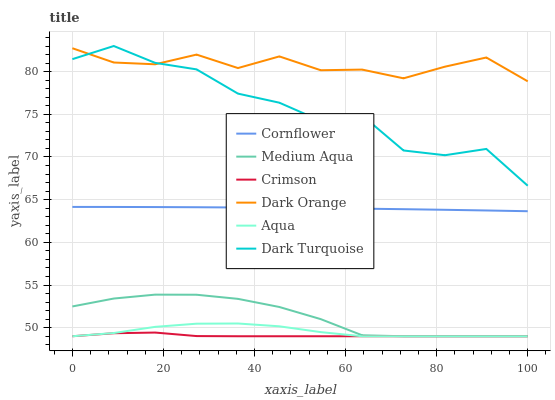Does Crimson have the minimum area under the curve?
Answer yes or no. Yes. Does Dark Orange have the maximum area under the curve?
Answer yes or no. Yes. Does Dark Turquoise have the minimum area under the curve?
Answer yes or no. No. Does Dark Turquoise have the maximum area under the curve?
Answer yes or no. No. Is Cornflower the smoothest?
Answer yes or no. Yes. Is Dark Turquoise the roughest?
Answer yes or no. Yes. Is Dark Orange the smoothest?
Answer yes or no. No. Is Dark Orange the roughest?
Answer yes or no. No. Does Aqua have the lowest value?
Answer yes or no. Yes. Does Dark Turquoise have the lowest value?
Answer yes or no. No. Does Dark Turquoise have the highest value?
Answer yes or no. Yes. Does Dark Orange have the highest value?
Answer yes or no. No. Is Cornflower less than Dark Turquoise?
Answer yes or no. Yes. Is Cornflower greater than Aqua?
Answer yes or no. Yes. Does Aqua intersect Crimson?
Answer yes or no. Yes. Is Aqua less than Crimson?
Answer yes or no. No. Is Aqua greater than Crimson?
Answer yes or no. No. Does Cornflower intersect Dark Turquoise?
Answer yes or no. No. 